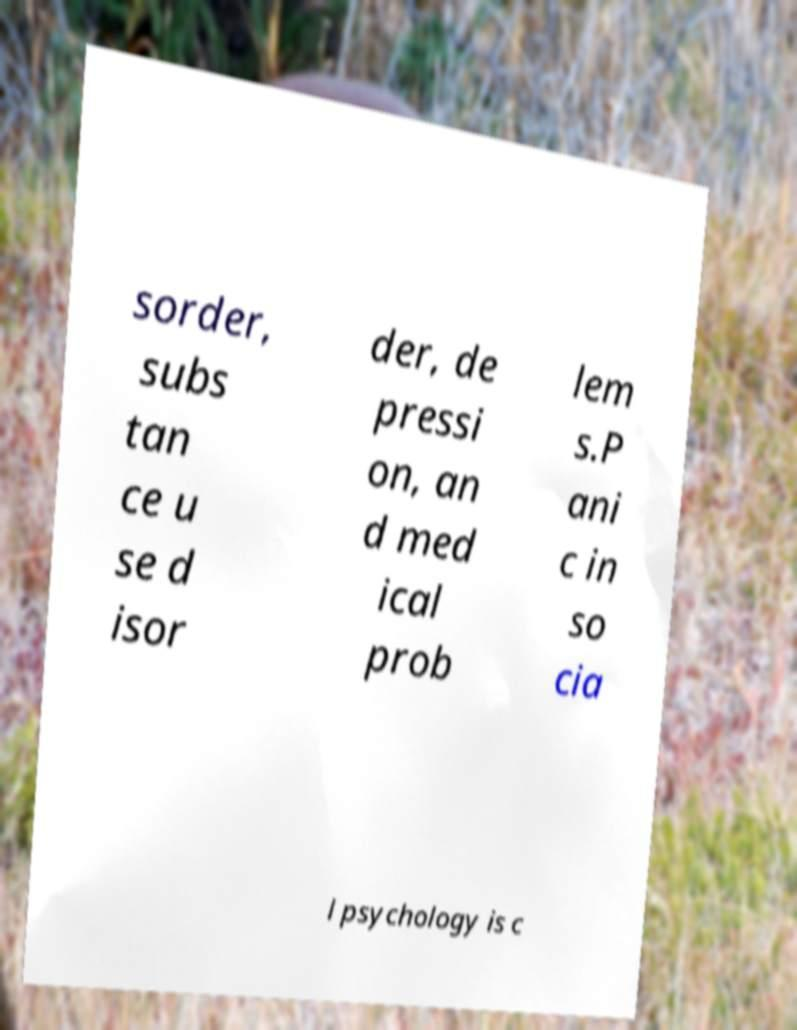Can you accurately transcribe the text from the provided image for me? sorder, subs tan ce u se d isor der, de pressi on, an d med ical prob lem s.P ani c in so cia l psychology is c 